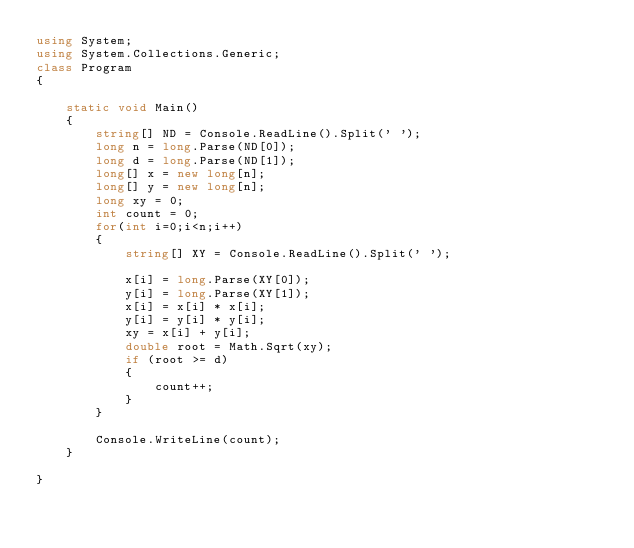Convert code to text. <code><loc_0><loc_0><loc_500><loc_500><_C#_>using System;
using System.Collections.Generic;
class Program
{

    static void Main()
    {
        string[] ND = Console.ReadLine().Split(' ');
        long n = long.Parse(ND[0]);
        long d = long.Parse(ND[1]);
        long[] x = new long[n];
        long[] y = new long[n];
        long xy = 0;
        int count = 0;
        for(int i=0;i<n;i++)
        {
            string[] XY = Console.ReadLine().Split(' ');
            
            x[i] = long.Parse(XY[0]);
            y[i] = long.Parse(XY[1]);
            x[i] = x[i] * x[i];
            y[i] = y[i] * y[i];
            xy = x[i] + y[i];
            double root = Math.Sqrt(xy);
            if (root >= d)
            {
                count++;
            }
        }

        Console.WriteLine(count);
    }

}

</code> 